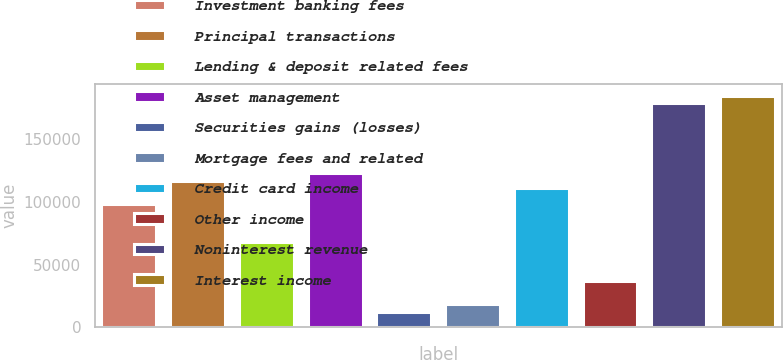Convert chart. <chart><loc_0><loc_0><loc_500><loc_500><bar_chart><fcel>Investment banking fees<fcel>Principal transactions<fcel>Lending & deposit related fees<fcel>Asset management<fcel>Securities gains (losses)<fcel>Mortgage fees and related<fcel>Credit card income<fcel>Other income<fcel>Noninterest revenue<fcel>Interest income<nl><fcel>98298.3<fcel>116729<fcel>67580.5<fcel>122873<fcel>12288.5<fcel>18432<fcel>110585<fcel>36862.7<fcel>178165<fcel>184308<nl></chart> 